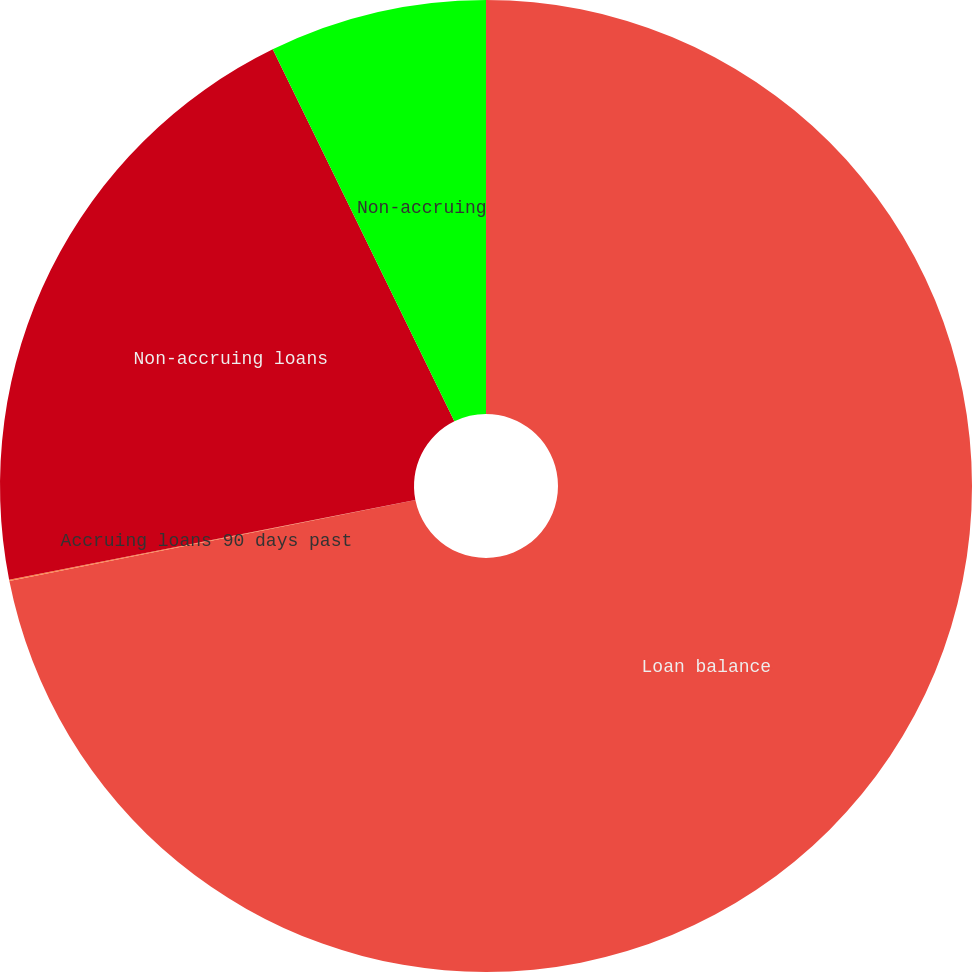<chart> <loc_0><loc_0><loc_500><loc_500><pie_chart><fcel>Loan balance<fcel>Accruing loans 90 days past<fcel>Non-accruing loans<fcel>Non-accruing<nl><fcel>71.87%<fcel>0.04%<fcel>20.86%<fcel>7.23%<nl></chart> 